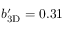Convert formula to latex. <formula><loc_0><loc_0><loc_500><loc_500>{ b _ { 3 D } ^ { \prime } } = 0 . 3 1</formula> 